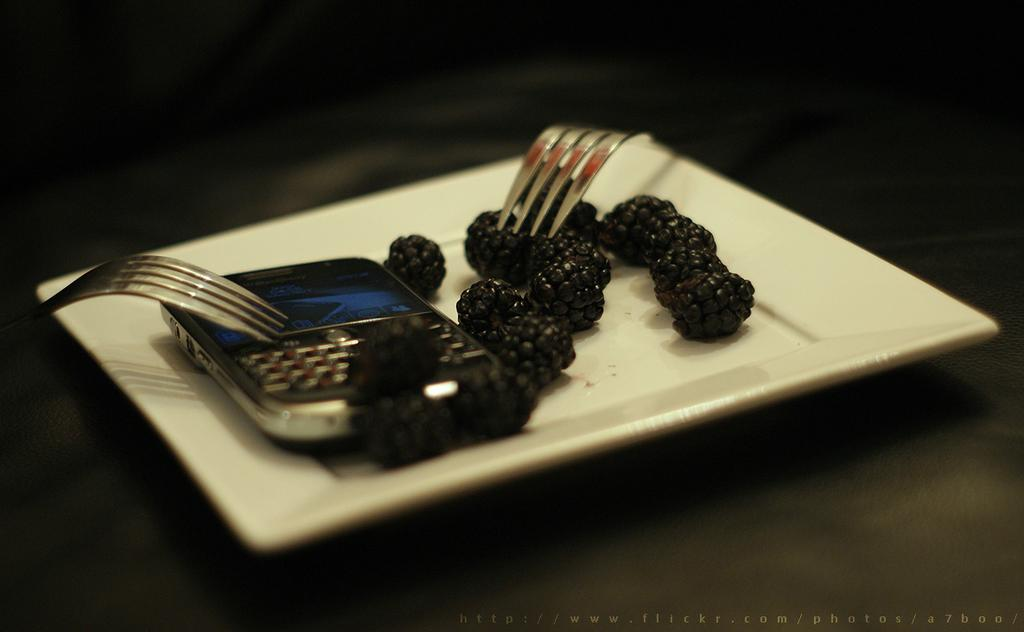What is on the plate that is visible in the image? The plate contains blackberries. Besides the plate, what other items can be seen in the image? There are forks and a phone visible in the image. What type of bead is being used to create the ice sculpture in the image? There is no ice sculpture or bead present in the image. What role does the actor play in the image? There is no actor present in the image. 